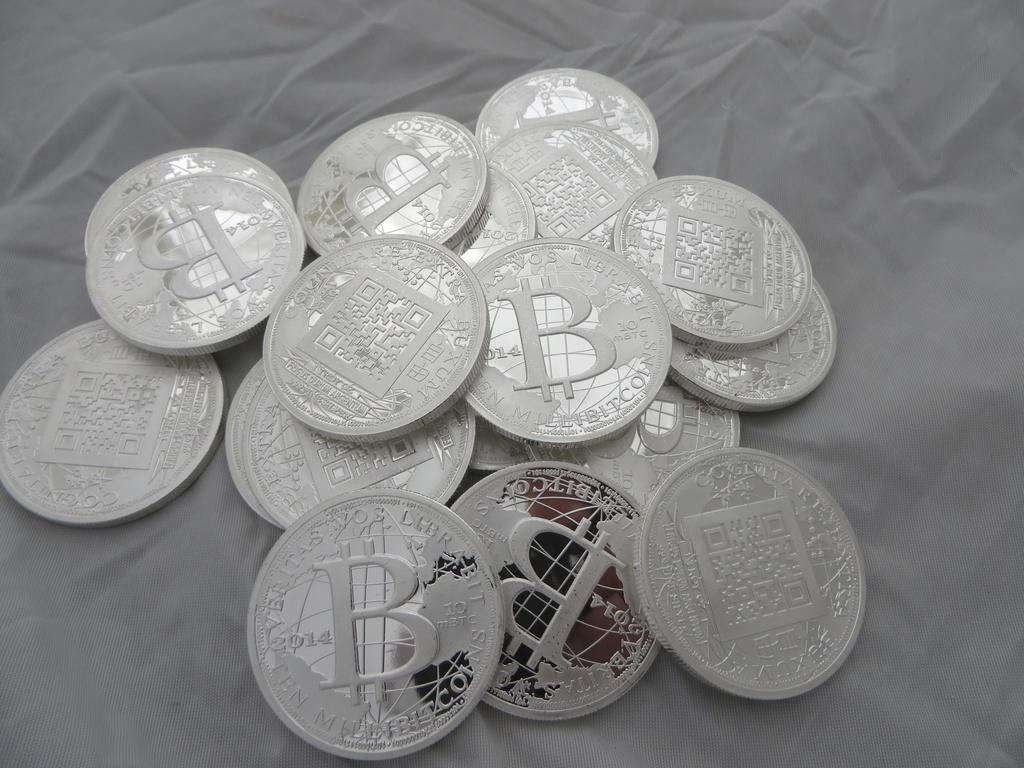Provide a one-sentence caption for the provided image. Shiny silver coins with the letter B on them sit in a small pile. 